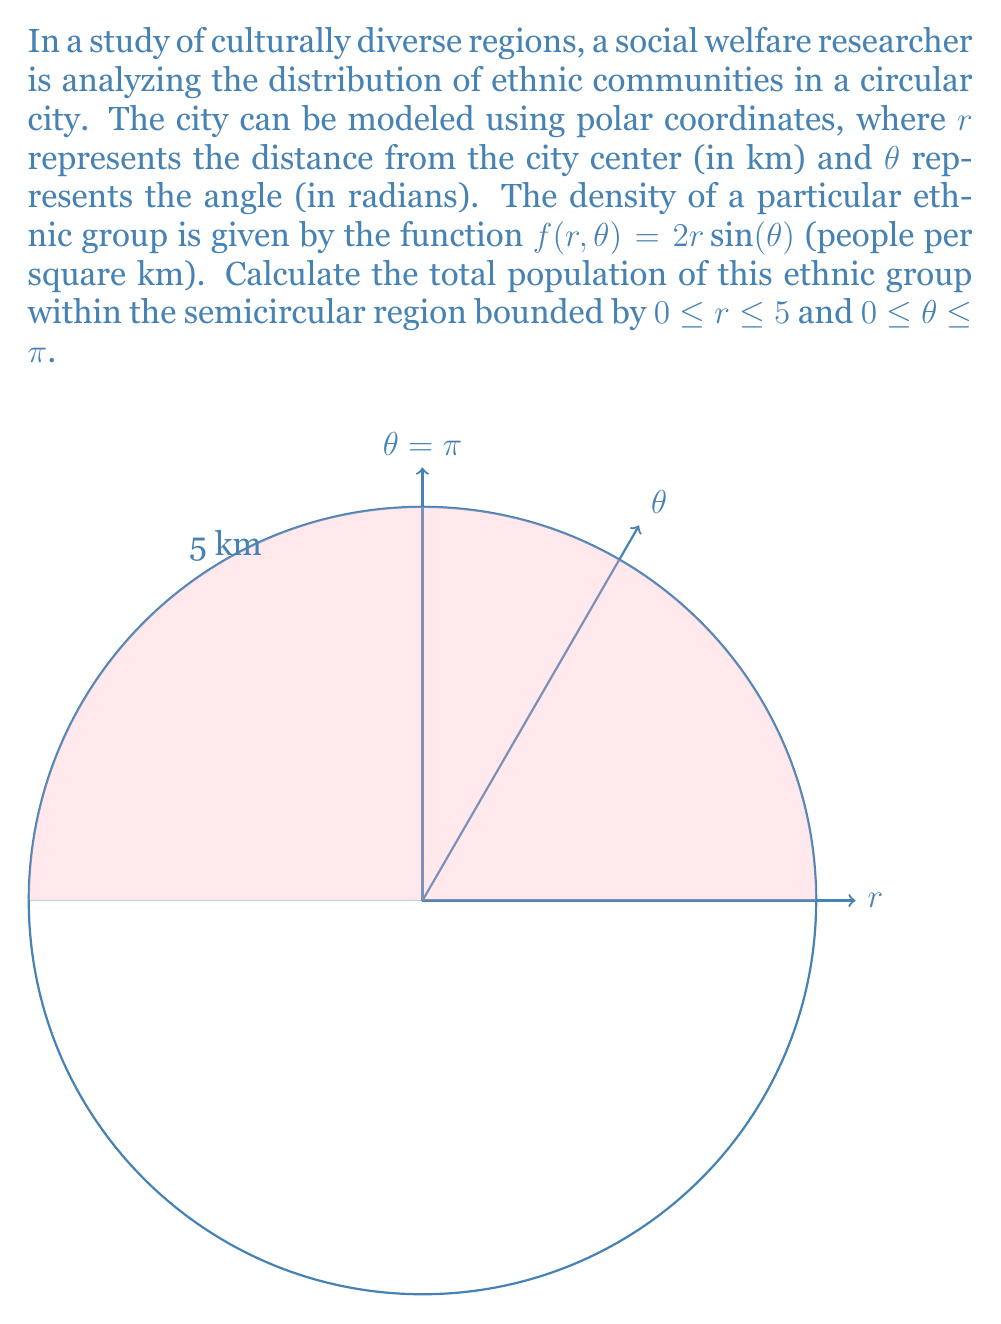Give your solution to this math problem. To solve this problem, we need to use polar integration. The steps are as follows:

1) In polar coordinates, the area element is given by $dA = r \, dr \, d\theta$.

2) The population density function is $f(r,\theta) = 2r\sin(\theta)$.

3) To find the total population, we need to integrate this density over the given region:

   $$P = \int_{0}^{\pi} \int_{0}^{5} f(r,\theta) \, r \, dr \, d\theta$$

4) Substituting the density function:

   $$P = \int_{0}^{\pi} \int_{0}^{5} 2r\sin(\theta) \, r \, dr \, d\theta$$

5) Simplify:

   $$P = 2 \int_{0}^{\pi} \sin(\theta) \int_{0}^{5} r^2 \, dr \, d\theta$$

6) Solve the inner integral:

   $$P = 2 \int_{0}^{\pi} \sin(\theta) \left[\frac{r^3}{3}\right]_{0}^{5} \, d\theta$$
   
   $$P = 2 \int_{0}^{\pi} \sin(\theta) \cdot \frac{125}{3} \, d\theta$$

7) Simplify:

   $$P = \frac{250}{3} \int_{0}^{\pi} \sin(\theta) \, d\theta$$

8) Solve the remaining integral:

   $$P = \frac{250}{3} [-\cos(\theta)]_{0}^{\pi}$$
   
   $$P = \frac{250}{3} [(-\cos(\pi)) - (-\cos(0))]$$
   
   $$P = \frac{250}{3} [1 - (-1)] = \frac{250}{3} \cdot 2$$

9) Simplify the final result:

   $$P = \frac{500}{3}$$

Therefore, the total population of the ethnic group in the given region is $\frac{500}{3}$ people.
Answer: $\frac{500}{3}$ people 